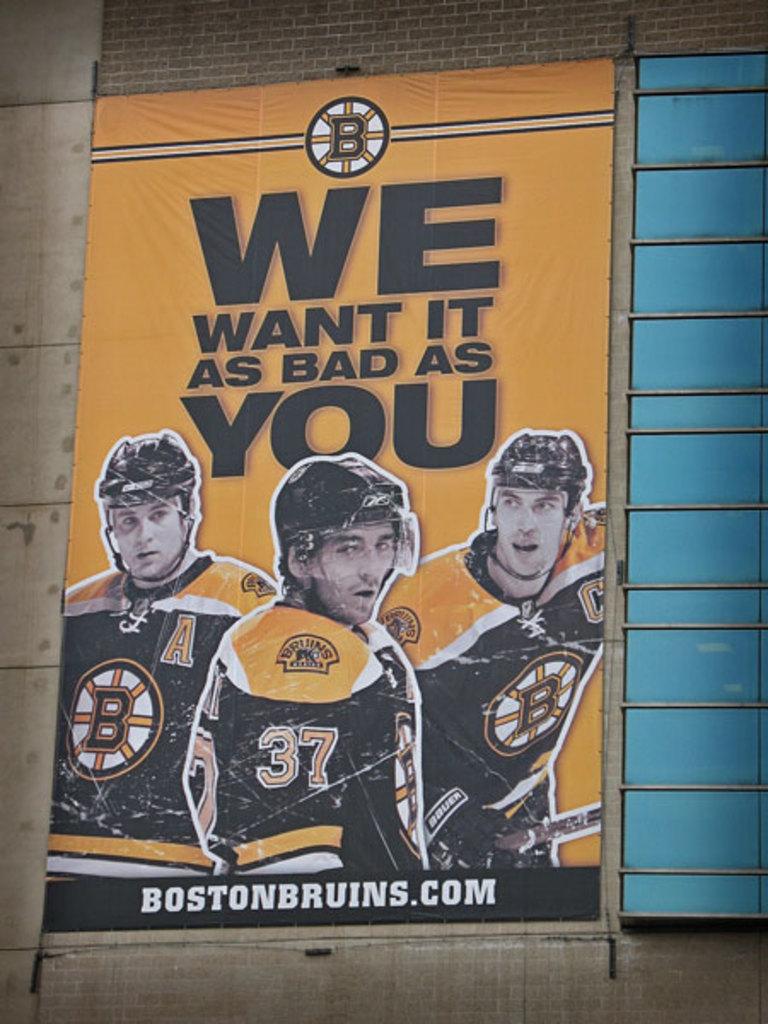Who wants it this bad?
Your answer should be very brief. We. What is the webpage?
Provide a short and direct response. Bostonbruins.com. 